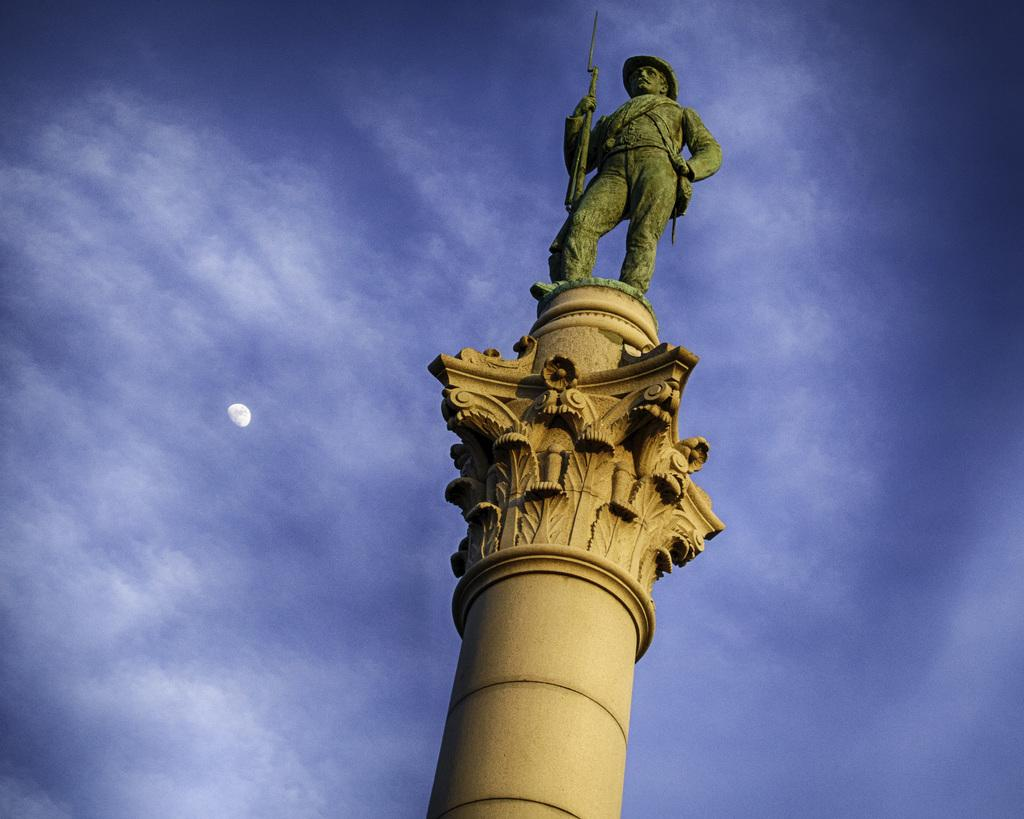What is the main structure in the image? There is a pillar in the image. What is on top of the pillar? There is a sculpture on the pillar. What can be seen in the background of the image? The sky and the moon are visible in the image. What type of bear can be seen singing songs in the image? There is no bear or singing in the image; it features a pillar with a sculpture and the sky with the moon. 